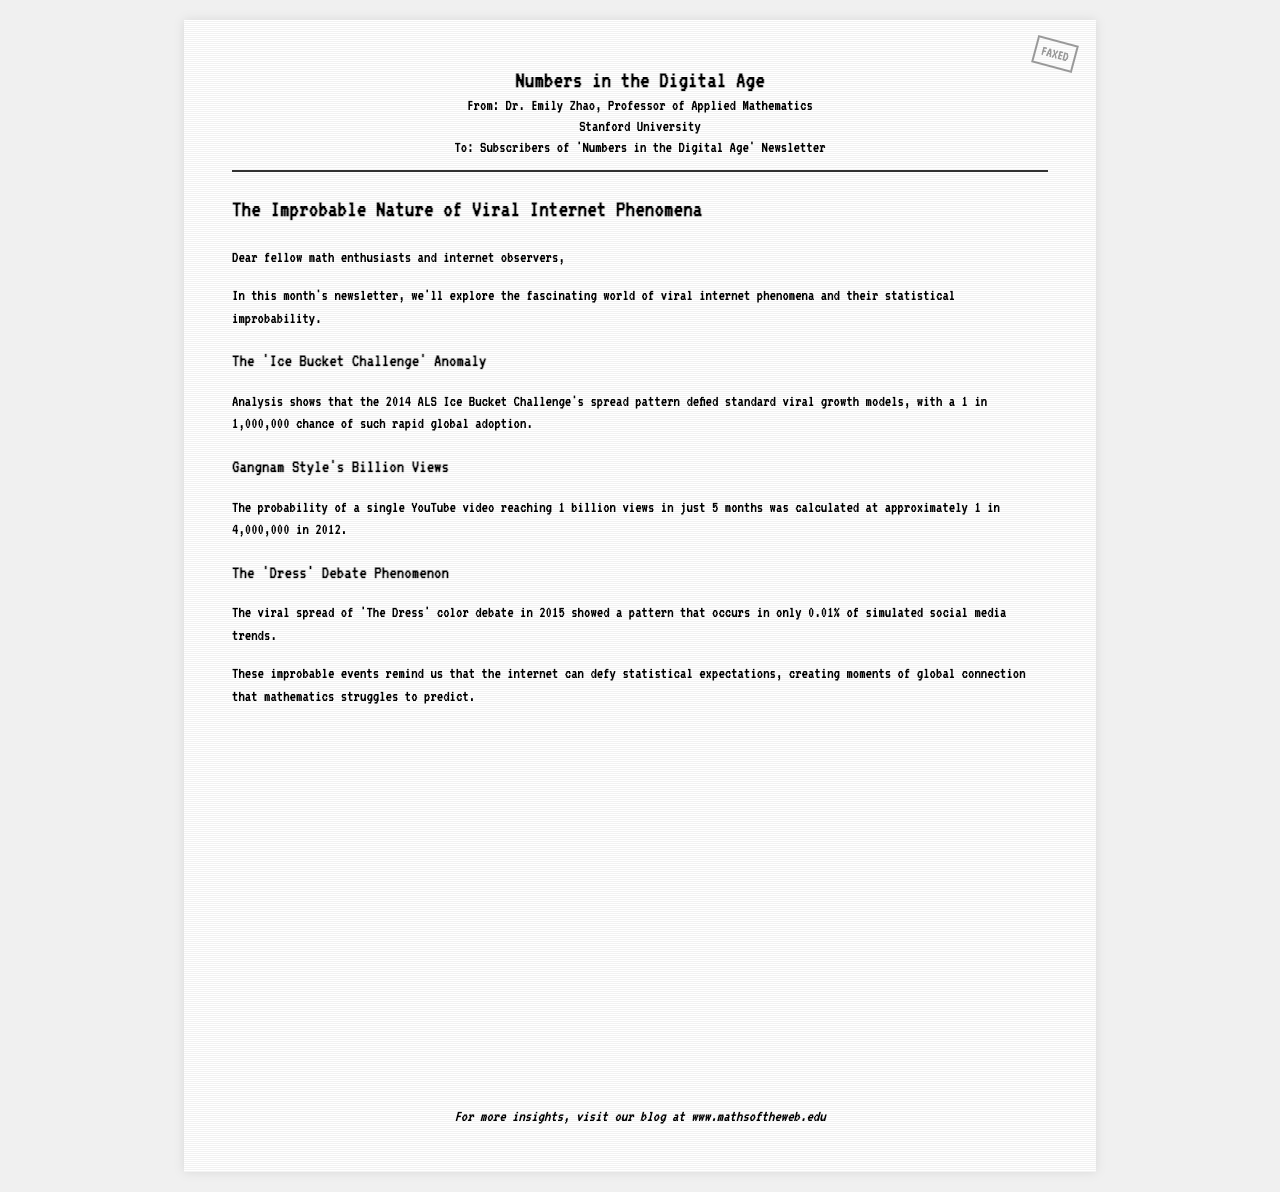What is the title of the newsletter? The title is stated prominently at the top of the document.
Answer: Numbers in the Digital Age Who is the author of the fax? The author's name is mentioned in the header section of the document.
Answer: Dr. Emily Zhao What university is Dr. Emily Zhao affiliated with? The university is specified in the header under the author's name.
Answer: Stanford University What was the probability of the Ice Bucket Challenge's rapid global adoption? This information is provided in the section discussing the Ice Bucket Challenge.
Answer: 1 in 1,000,000 In what year did the viral 'Dress' debate occur? The year is mentioned in the section about the color debate phenomenon.
Answer: 2015 What percentage of simulated social media trends shows the pattern of 'The Dress'? This percentage is provided in the content of the document.
Answer: 0.01% What was the probability of a YouTube video reaching 1 billion views in just 5 months? The specific probability is mentioned in the section about Gangnam Style.
Answer: 1 in 4,000,000 What is the main theme of this faxed newsletter? The theme is introduced in the opening paragraph and further discussed.
Answer: Statistical improbability How can readers find more insights according to the document? The footer suggests a specific action for readers seeking further information.
Answer: Visit our blog at www.mathsoftheweb.edu 